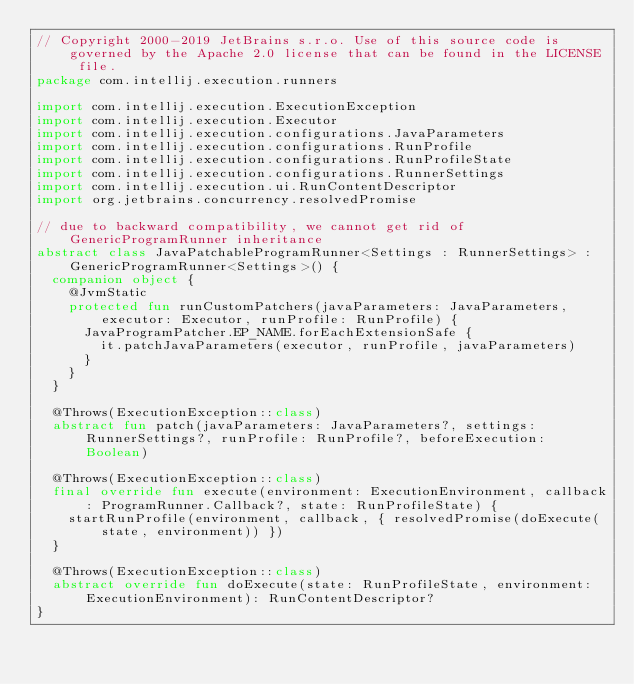Convert code to text. <code><loc_0><loc_0><loc_500><loc_500><_Kotlin_>// Copyright 2000-2019 JetBrains s.r.o. Use of this source code is governed by the Apache 2.0 license that can be found in the LICENSE file.
package com.intellij.execution.runners

import com.intellij.execution.ExecutionException
import com.intellij.execution.Executor
import com.intellij.execution.configurations.JavaParameters
import com.intellij.execution.configurations.RunProfile
import com.intellij.execution.configurations.RunProfileState
import com.intellij.execution.configurations.RunnerSettings
import com.intellij.execution.ui.RunContentDescriptor
import org.jetbrains.concurrency.resolvedPromise

// due to backward compatibility, we cannot get rid of GenericProgramRunner inheritance
abstract class JavaPatchableProgramRunner<Settings : RunnerSettings> : GenericProgramRunner<Settings>() {
  companion object {
    @JvmStatic
    protected fun runCustomPatchers(javaParameters: JavaParameters, executor: Executor, runProfile: RunProfile) {
      JavaProgramPatcher.EP_NAME.forEachExtensionSafe {
        it.patchJavaParameters(executor, runProfile, javaParameters)
      }
    }
  }

  @Throws(ExecutionException::class)
  abstract fun patch(javaParameters: JavaParameters?, settings: RunnerSettings?, runProfile: RunProfile?, beforeExecution: Boolean)

  @Throws(ExecutionException::class)
  final override fun execute(environment: ExecutionEnvironment, callback: ProgramRunner.Callback?, state: RunProfileState) {
    startRunProfile(environment, callback, { resolvedPromise(doExecute(state, environment)) })
  }

  @Throws(ExecutionException::class)
  abstract override fun doExecute(state: RunProfileState, environment: ExecutionEnvironment): RunContentDescriptor?
}</code> 